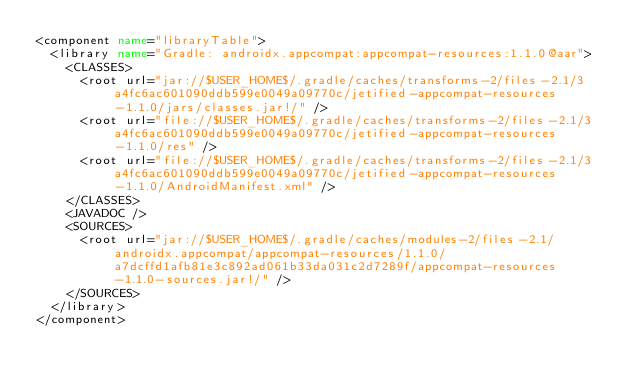Convert code to text. <code><loc_0><loc_0><loc_500><loc_500><_XML_><component name="libraryTable">
  <library name="Gradle: androidx.appcompat:appcompat-resources:1.1.0@aar">
    <CLASSES>
      <root url="jar://$USER_HOME$/.gradle/caches/transforms-2/files-2.1/3a4fc6ac601090ddb599e0049a09770c/jetified-appcompat-resources-1.1.0/jars/classes.jar!/" />
      <root url="file://$USER_HOME$/.gradle/caches/transforms-2/files-2.1/3a4fc6ac601090ddb599e0049a09770c/jetified-appcompat-resources-1.1.0/res" />
      <root url="file://$USER_HOME$/.gradle/caches/transforms-2/files-2.1/3a4fc6ac601090ddb599e0049a09770c/jetified-appcompat-resources-1.1.0/AndroidManifest.xml" />
    </CLASSES>
    <JAVADOC />
    <SOURCES>
      <root url="jar://$USER_HOME$/.gradle/caches/modules-2/files-2.1/androidx.appcompat/appcompat-resources/1.1.0/a7dcffd1afb81e3c892ad061b33da031c2d7289f/appcompat-resources-1.1.0-sources.jar!/" />
    </SOURCES>
  </library>
</component></code> 